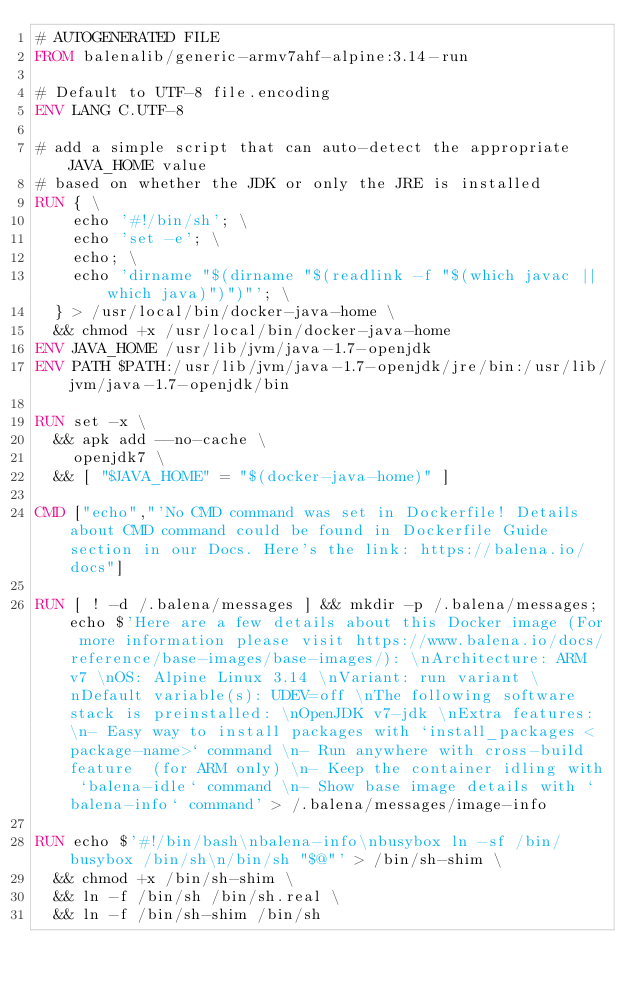Convert code to text. <code><loc_0><loc_0><loc_500><loc_500><_Dockerfile_># AUTOGENERATED FILE
FROM balenalib/generic-armv7ahf-alpine:3.14-run

# Default to UTF-8 file.encoding
ENV LANG C.UTF-8

# add a simple script that can auto-detect the appropriate JAVA_HOME value
# based on whether the JDK or only the JRE is installed
RUN { \
		echo '#!/bin/sh'; \
		echo 'set -e'; \
		echo; \
		echo 'dirname "$(dirname "$(readlink -f "$(which javac || which java)")")"'; \
	} > /usr/local/bin/docker-java-home \
	&& chmod +x /usr/local/bin/docker-java-home
ENV JAVA_HOME /usr/lib/jvm/java-1.7-openjdk
ENV PATH $PATH:/usr/lib/jvm/java-1.7-openjdk/jre/bin:/usr/lib/jvm/java-1.7-openjdk/bin

RUN set -x \
	&& apk add --no-cache \
		openjdk7 \
	&& [ "$JAVA_HOME" = "$(docker-java-home)" ]

CMD ["echo","'No CMD command was set in Dockerfile! Details about CMD command could be found in Dockerfile Guide section in our Docs. Here's the link: https://balena.io/docs"]

RUN [ ! -d /.balena/messages ] && mkdir -p /.balena/messages; echo $'Here are a few details about this Docker image (For more information please visit https://www.balena.io/docs/reference/base-images/base-images/): \nArchitecture: ARM v7 \nOS: Alpine Linux 3.14 \nVariant: run variant \nDefault variable(s): UDEV=off \nThe following software stack is preinstalled: \nOpenJDK v7-jdk \nExtra features: \n- Easy way to install packages with `install_packages <package-name>` command \n- Run anywhere with cross-build feature  (for ARM only) \n- Keep the container idling with `balena-idle` command \n- Show base image details with `balena-info` command' > /.balena/messages/image-info

RUN echo $'#!/bin/bash\nbalena-info\nbusybox ln -sf /bin/busybox /bin/sh\n/bin/sh "$@"' > /bin/sh-shim \
	&& chmod +x /bin/sh-shim \
	&& ln -f /bin/sh /bin/sh.real \
	&& ln -f /bin/sh-shim /bin/sh</code> 